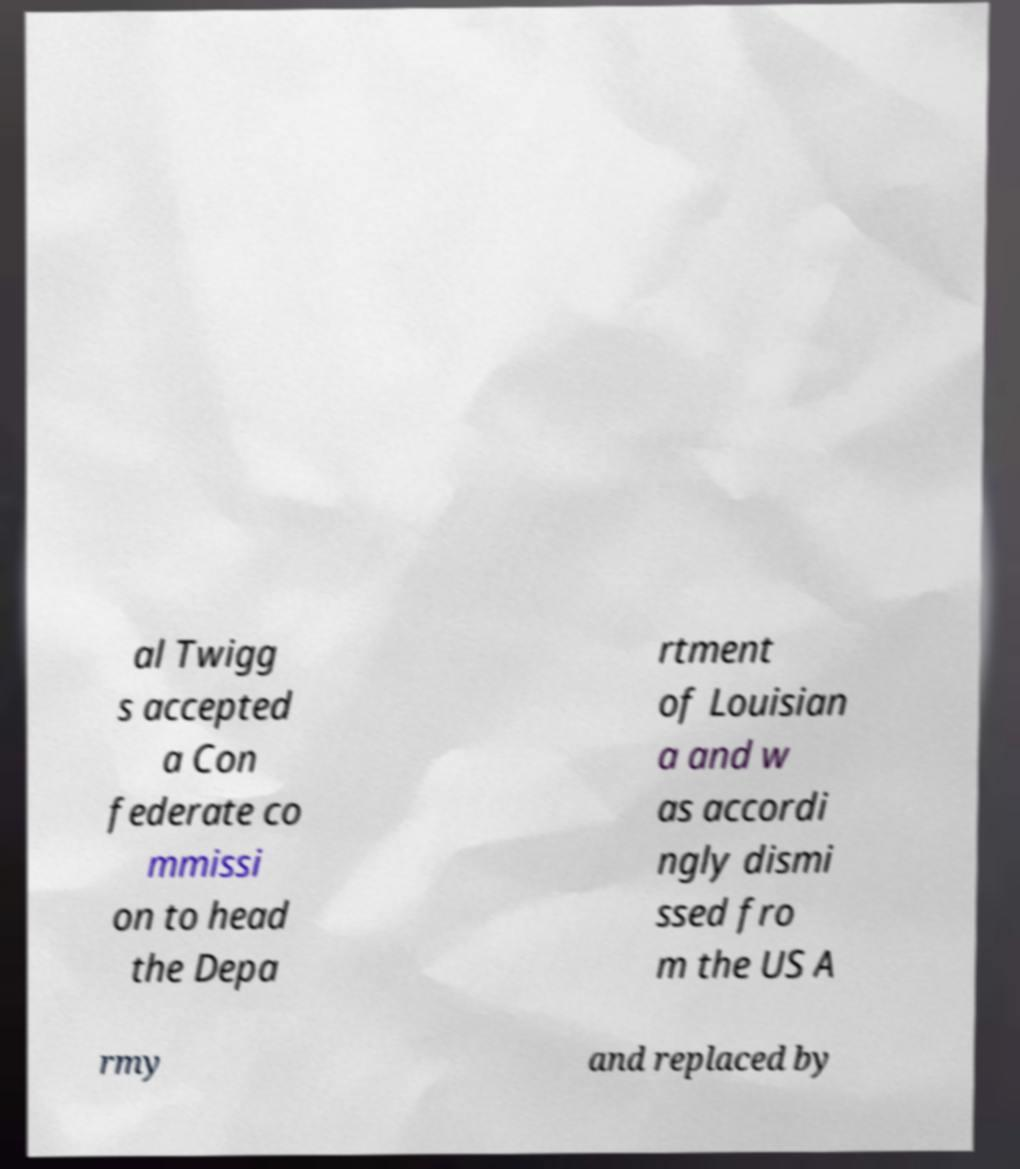Can you accurately transcribe the text from the provided image for me? al Twigg s accepted a Con federate co mmissi on to head the Depa rtment of Louisian a and w as accordi ngly dismi ssed fro m the US A rmy and replaced by 